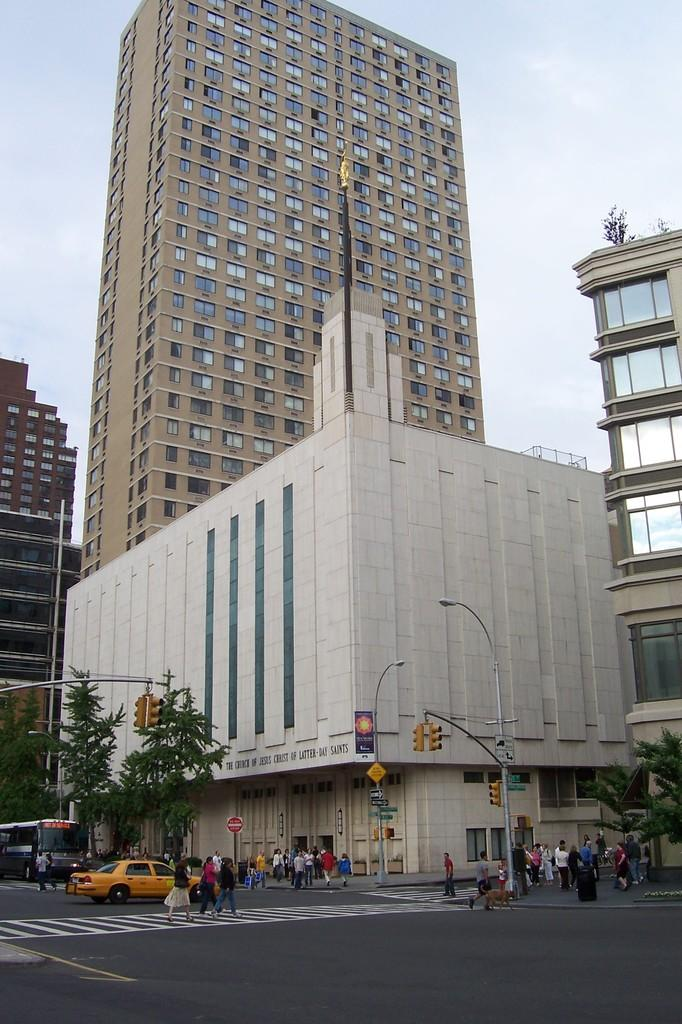How many people can be seen in the image? There are people in the image, but the exact number is not specified. What types of vehicles are present in the image? There are vehicles in the image, but the specific types are not mentioned. What are the poles used for in the image? The purpose of the poles is not specified in the image. What are the boards used for in the image? The purpose of the boards is not specified in the image. What is the condition of the road in the image? The condition of the road is not specified in the image. What type of trees can be seen in the image? The type of trees is not specified in the image. What are the buildings in the image used for? The purpose of the buildings is not specified in the image. What can be seen in the background of the image? The sky is visible in the background of the image. What type of weather can be seen in the image? The type of weather is not specified in the image. Can you tell me how many tramps are visible in the image? There is no mention of a tramp or any similar object in the image. 